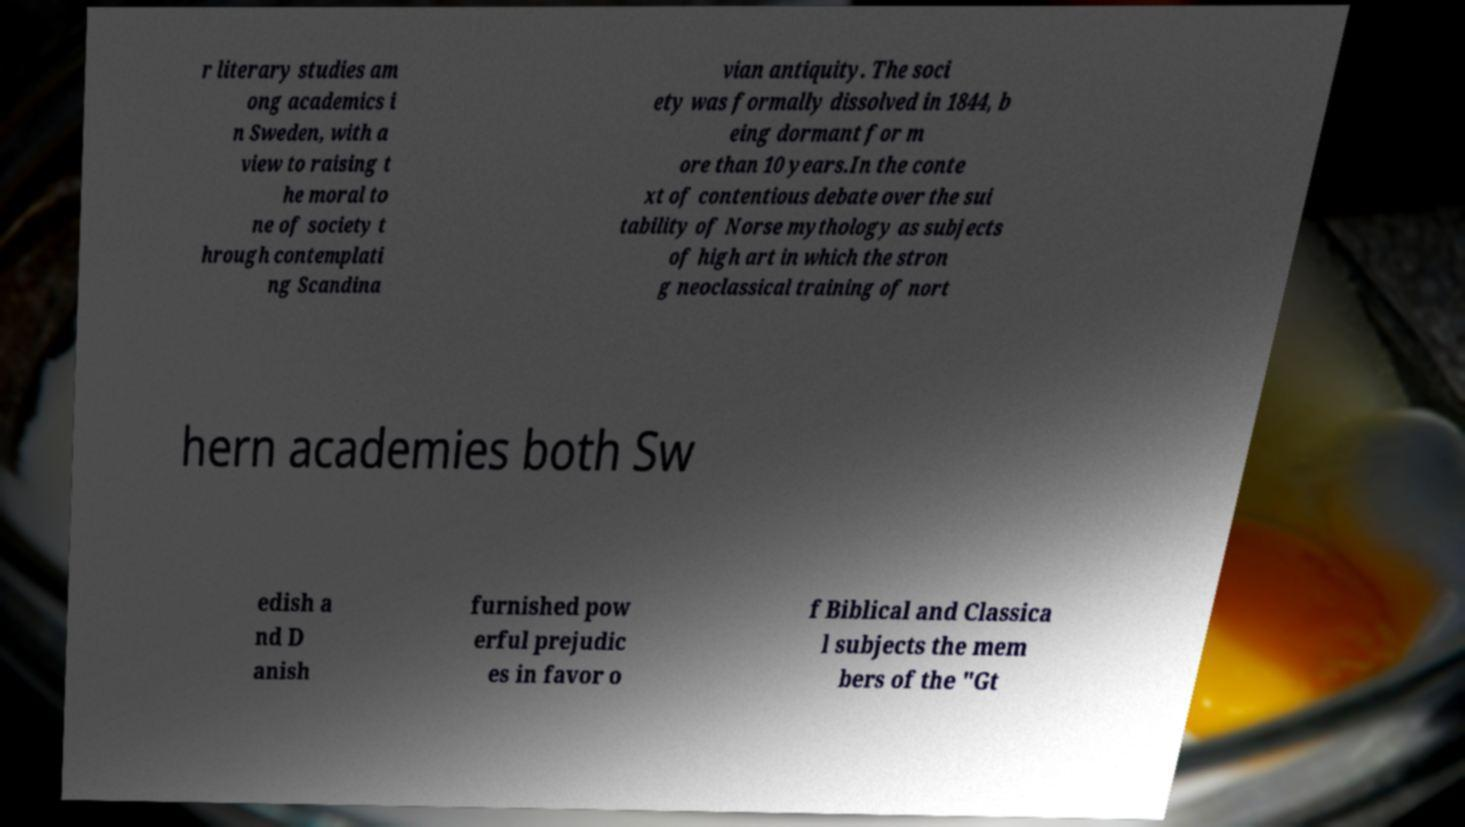Can you accurately transcribe the text from the provided image for me? r literary studies am ong academics i n Sweden, with a view to raising t he moral to ne of society t hrough contemplati ng Scandina vian antiquity. The soci ety was formally dissolved in 1844, b eing dormant for m ore than 10 years.In the conte xt of contentious debate over the sui tability of Norse mythology as subjects of high art in which the stron g neoclassical training of nort hern academies both Sw edish a nd D anish furnished pow erful prejudic es in favor o f Biblical and Classica l subjects the mem bers of the "Gt 